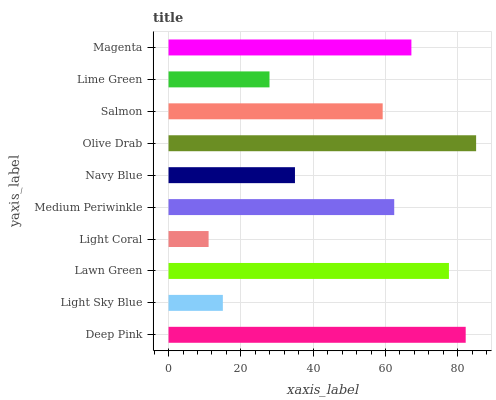Is Light Coral the minimum?
Answer yes or no. Yes. Is Olive Drab the maximum?
Answer yes or no. Yes. Is Light Sky Blue the minimum?
Answer yes or no. No. Is Light Sky Blue the maximum?
Answer yes or no. No. Is Deep Pink greater than Light Sky Blue?
Answer yes or no. Yes. Is Light Sky Blue less than Deep Pink?
Answer yes or no. Yes. Is Light Sky Blue greater than Deep Pink?
Answer yes or no. No. Is Deep Pink less than Light Sky Blue?
Answer yes or no. No. Is Medium Periwinkle the high median?
Answer yes or no. Yes. Is Salmon the low median?
Answer yes or no. Yes. Is Light Coral the high median?
Answer yes or no. No. Is Magenta the low median?
Answer yes or no. No. 